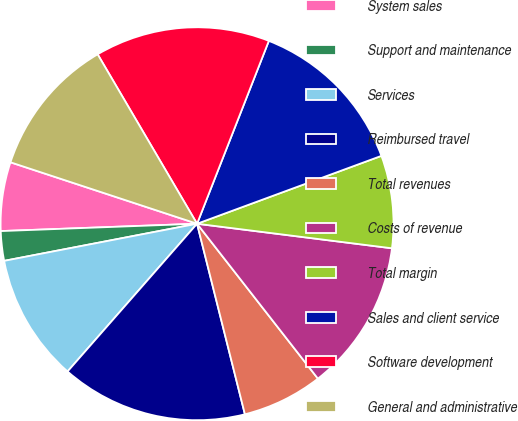Convert chart to OTSL. <chart><loc_0><loc_0><loc_500><loc_500><pie_chart><fcel>System sales<fcel>Support and maintenance<fcel>Services<fcel>Reimbursed travel<fcel>Total revenues<fcel>Costs of revenue<fcel>Total margin<fcel>Sales and client service<fcel>Software development<fcel>General and administrative<nl><fcel>5.66%<fcel>2.43%<fcel>10.52%<fcel>15.37%<fcel>6.63%<fcel>12.46%<fcel>7.61%<fcel>13.43%<fcel>14.4%<fcel>11.49%<nl></chart> 